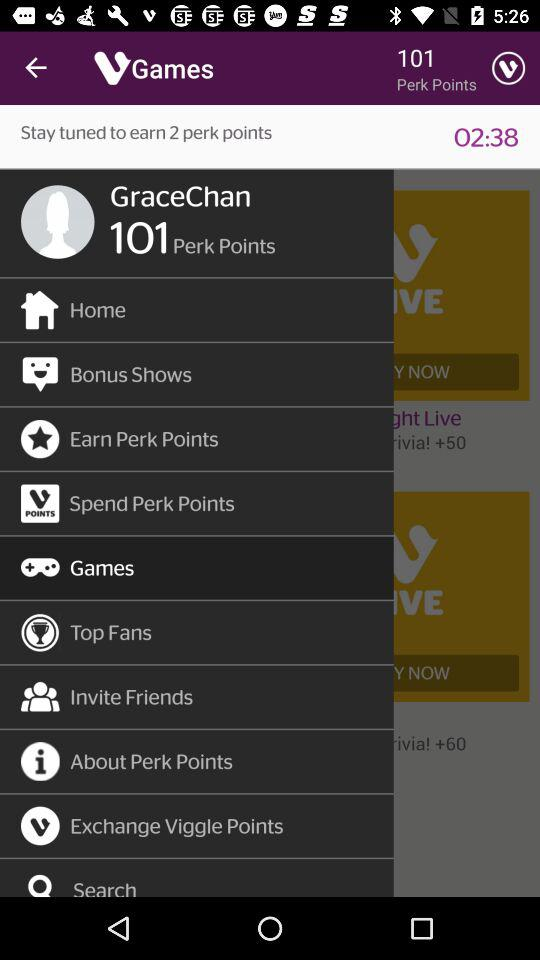What is the username? The username is "GraceChan". 